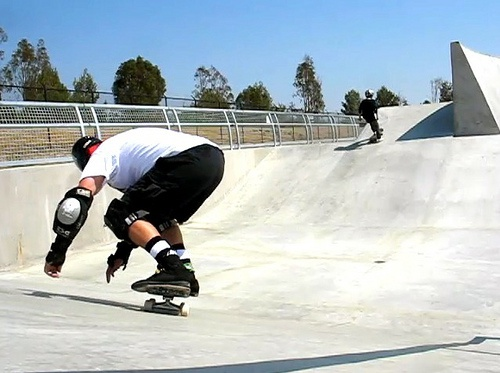Describe the objects in this image and their specific colors. I can see people in darkgray, black, white, and gray tones, skateboard in darkgray, black, and gray tones, people in darkgray, black, gray, and lightgray tones, and skateboard in darkgray, black, and gray tones in this image. 